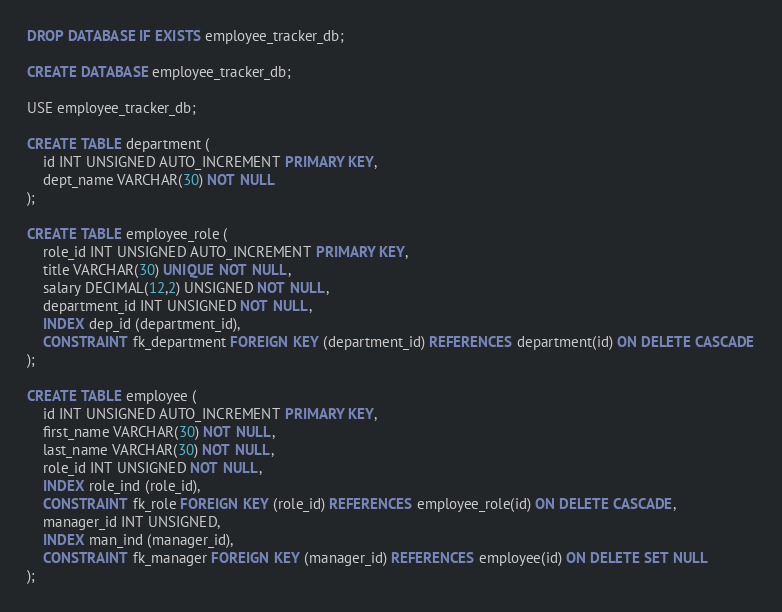<code> <loc_0><loc_0><loc_500><loc_500><_SQL_>DROP DATABASE IF EXISTS employee_tracker_db;

CREATE DATABASE employee_tracker_db;

USE employee_tracker_db;

CREATE TABLE department (
    id INT UNSIGNED AUTO_INCREMENT PRIMARY KEY,
    dept_name VARCHAR(30) NOT NULL
);

CREATE TABLE employee_role (
    role_id INT UNSIGNED AUTO_INCREMENT PRIMARY KEY,
    title VARCHAR(30) UNIQUE NOT NULL,
    salary DECIMAL(12,2) UNSIGNED NOT NULL,
    department_id INT UNSIGNED NOT NULL,
    INDEX dep_id (department_id),
    CONSTRAINT fk_department FOREIGN KEY (department_id) REFERENCES department(id) ON DELETE CASCADE
);

CREATE TABLE employee (
    id INT UNSIGNED AUTO_INCREMENT PRIMARY KEY,
    first_name VARCHAR(30) NOT NULL,
    last_name VARCHAR(30) NOT NULL,
    role_id INT UNSIGNED NOT NULL,
    INDEX role_ind (role_id),
    CONSTRAINT fk_role FOREIGN KEY (role_id) REFERENCES employee_role(id) ON DELETE CASCADE,
    manager_id INT UNSIGNED,
    INDEX man_ind (manager_id),
    CONSTRAINT fk_manager FOREIGN KEY (manager_id) REFERENCES employee(id) ON DELETE SET NULL
);
</code> 